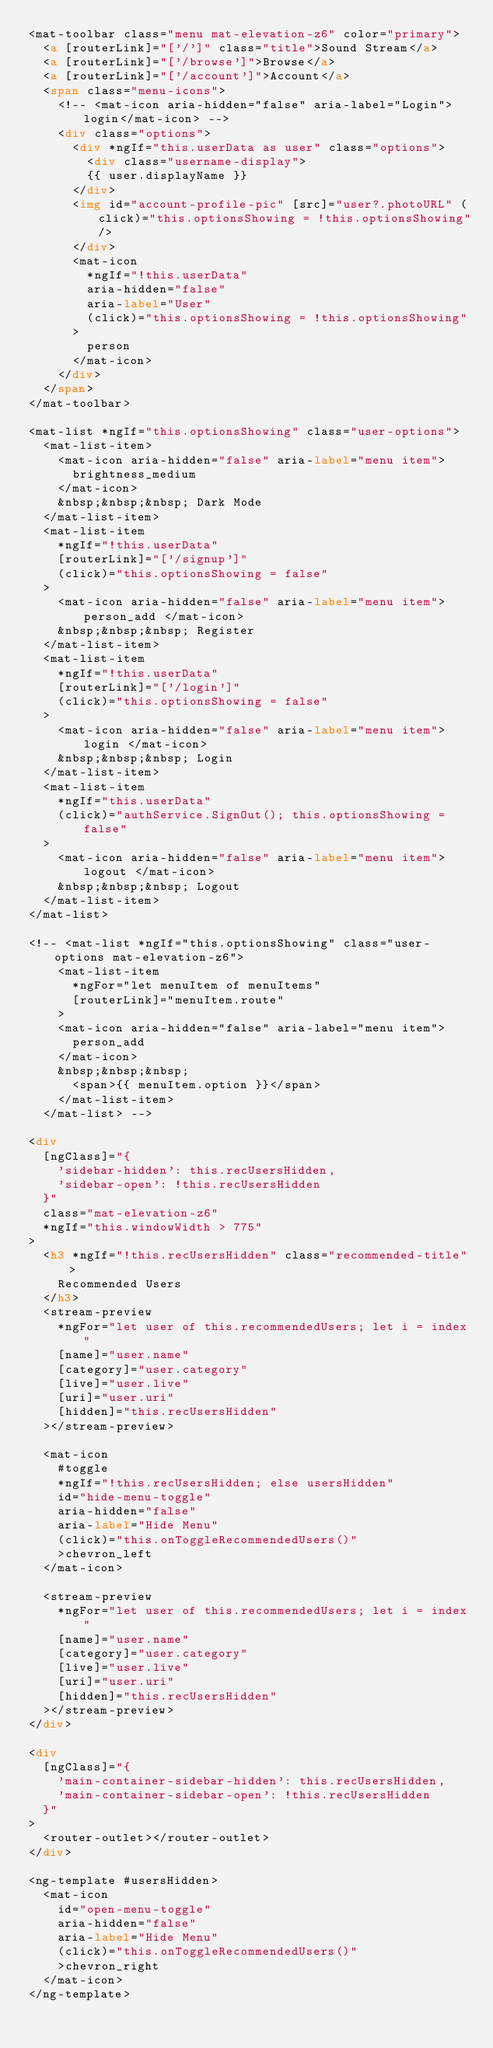<code> <loc_0><loc_0><loc_500><loc_500><_HTML_><mat-toolbar class="menu mat-elevation-z6" color="primary">
  <a [routerLink]="['/']" class="title">Sound Stream</a>
  <a [routerLink]="['/browse']">Browse</a>
  <a [routerLink]="['/account']">Account</a>
  <span class="menu-icons">
    <!-- <mat-icon aria-hidden="false" aria-label="Login">login</mat-icon> -->
    <div class="options">
      <div *ngIf="this.userData as user" class="options">
        <div class="username-display">
        {{ user.displayName }}
      </div>
      <img id="account-profile-pic" [src]="user?.photoURL" (click)="this.optionsShowing = !this.optionsShowing"/>
      </div>
      <mat-icon
        *ngIf="!this.userData"
        aria-hidden="false"
        aria-label="User"
        (click)="this.optionsShowing = !this.optionsShowing"
      >
        person
      </mat-icon>
    </div>
  </span>
</mat-toolbar>

<mat-list *ngIf="this.optionsShowing" class="user-options">
  <mat-list-item>
    <mat-icon aria-hidden="false" aria-label="menu item">
      brightness_medium
    </mat-icon>
    &nbsp;&nbsp;&nbsp; Dark Mode
  </mat-list-item>
  <mat-list-item
    *ngIf="!this.userData"
    [routerLink]="['/signup']"
    (click)="this.optionsShowing = false"
  >
    <mat-icon aria-hidden="false" aria-label="menu item"> person_add </mat-icon>
    &nbsp;&nbsp;&nbsp; Register
  </mat-list-item>
  <mat-list-item
    *ngIf="!this.userData"
    [routerLink]="['/login']"
    (click)="this.optionsShowing = false"
  >
    <mat-icon aria-hidden="false" aria-label="menu item"> login </mat-icon>
    &nbsp;&nbsp;&nbsp; Login
  </mat-list-item>
  <mat-list-item
    *ngIf="this.userData"
    (click)="authService.SignOut(); this.optionsShowing = false"
  >
    <mat-icon aria-hidden="false" aria-label="menu item"> logout </mat-icon>
    &nbsp;&nbsp;&nbsp; Logout
  </mat-list-item>
</mat-list>

<!-- <mat-list *ngIf="this.optionsShowing" class="user-options mat-elevation-z6">
    <mat-list-item
      *ngFor="let menuItem of menuItems"
      [routerLink]="menuItem.route"
    >
    <mat-icon aria-hidden="false" aria-label="menu item">
      person_add
    </mat-icon>
    &nbsp;&nbsp;&nbsp;
      <span>{{ menuItem.option }}</span>
    </mat-list-item>
  </mat-list> -->

<div
  [ngClass]="{
    'sidebar-hidden': this.recUsersHidden,
    'sidebar-open': !this.recUsersHidden
  }"
  class="mat-elevation-z6"
  *ngIf="this.windowWidth > 775"
>
  <h3 *ngIf="!this.recUsersHidden" class="recommended-title">
    Recommended Users
  </h3>
  <stream-preview
    *ngFor="let user of this.recommendedUsers; let i = index"
    [name]="user.name"
    [category]="user.category"
    [live]="user.live"
    [uri]="user.uri"
    [hidden]="this.recUsersHidden"
  ></stream-preview>

  <mat-icon
    #toggle
    *ngIf="!this.recUsersHidden; else usersHidden"
    id="hide-menu-toggle"
    aria-hidden="false"
    aria-label="Hide Menu"
    (click)="this.onToggleRecommendedUsers()"
    >chevron_left
  </mat-icon>

  <stream-preview
    *ngFor="let user of this.recommendedUsers; let i = index"
    [name]="user.name"
    [category]="user.category"
    [live]="user.live"
    [uri]="user.uri"
    [hidden]="this.recUsersHidden"
  ></stream-preview>
</div>

<div
  [ngClass]="{
    'main-container-sidebar-hidden': this.recUsersHidden,
    'main-container-sidebar-open': !this.recUsersHidden
  }"
>
  <router-outlet></router-outlet>
</div>

<ng-template #usersHidden>
  <mat-icon
    id="open-menu-toggle"
    aria-hidden="false"
    aria-label="Hide Menu"
    (click)="this.onToggleRecommendedUsers()"
    >chevron_right
  </mat-icon>
</ng-template>
</code> 